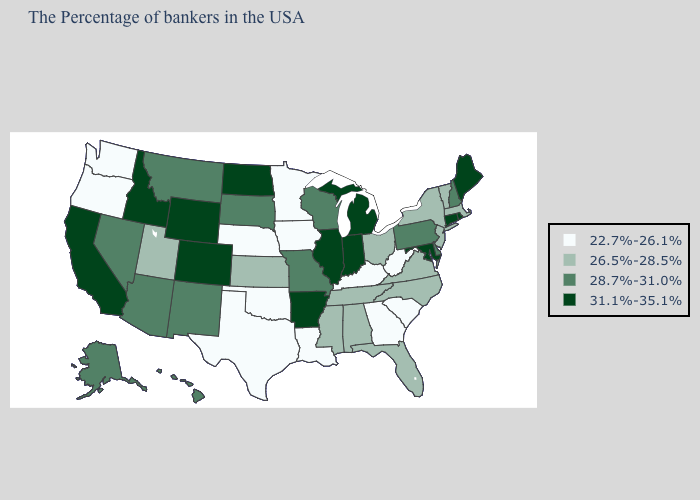What is the value of Delaware?
Short answer required. 28.7%-31.0%. What is the highest value in the Northeast ?
Quick response, please. 31.1%-35.1%. What is the value of Hawaii?
Give a very brief answer. 28.7%-31.0%. Which states have the highest value in the USA?
Quick response, please. Maine, Rhode Island, Connecticut, Maryland, Michigan, Indiana, Illinois, Arkansas, North Dakota, Wyoming, Colorado, Idaho, California. What is the highest value in states that border Iowa?
Short answer required. 31.1%-35.1%. Does Georgia have a lower value than Minnesota?
Short answer required. No. Does Kentucky have the lowest value in the USA?
Concise answer only. Yes. What is the lowest value in the Northeast?
Be succinct. 26.5%-28.5%. Does Hawaii have the lowest value in the West?
Short answer required. No. Among the states that border Michigan , does Ohio have the lowest value?
Keep it brief. Yes. Name the states that have a value in the range 26.5%-28.5%?
Give a very brief answer. Massachusetts, Vermont, New York, New Jersey, Virginia, North Carolina, Ohio, Florida, Alabama, Tennessee, Mississippi, Kansas, Utah. What is the value of New Hampshire?
Write a very short answer. 28.7%-31.0%. What is the highest value in the MidWest ?
Quick response, please. 31.1%-35.1%. Does the map have missing data?
Short answer required. No. Among the states that border Connecticut , does Rhode Island have the lowest value?
Short answer required. No. 